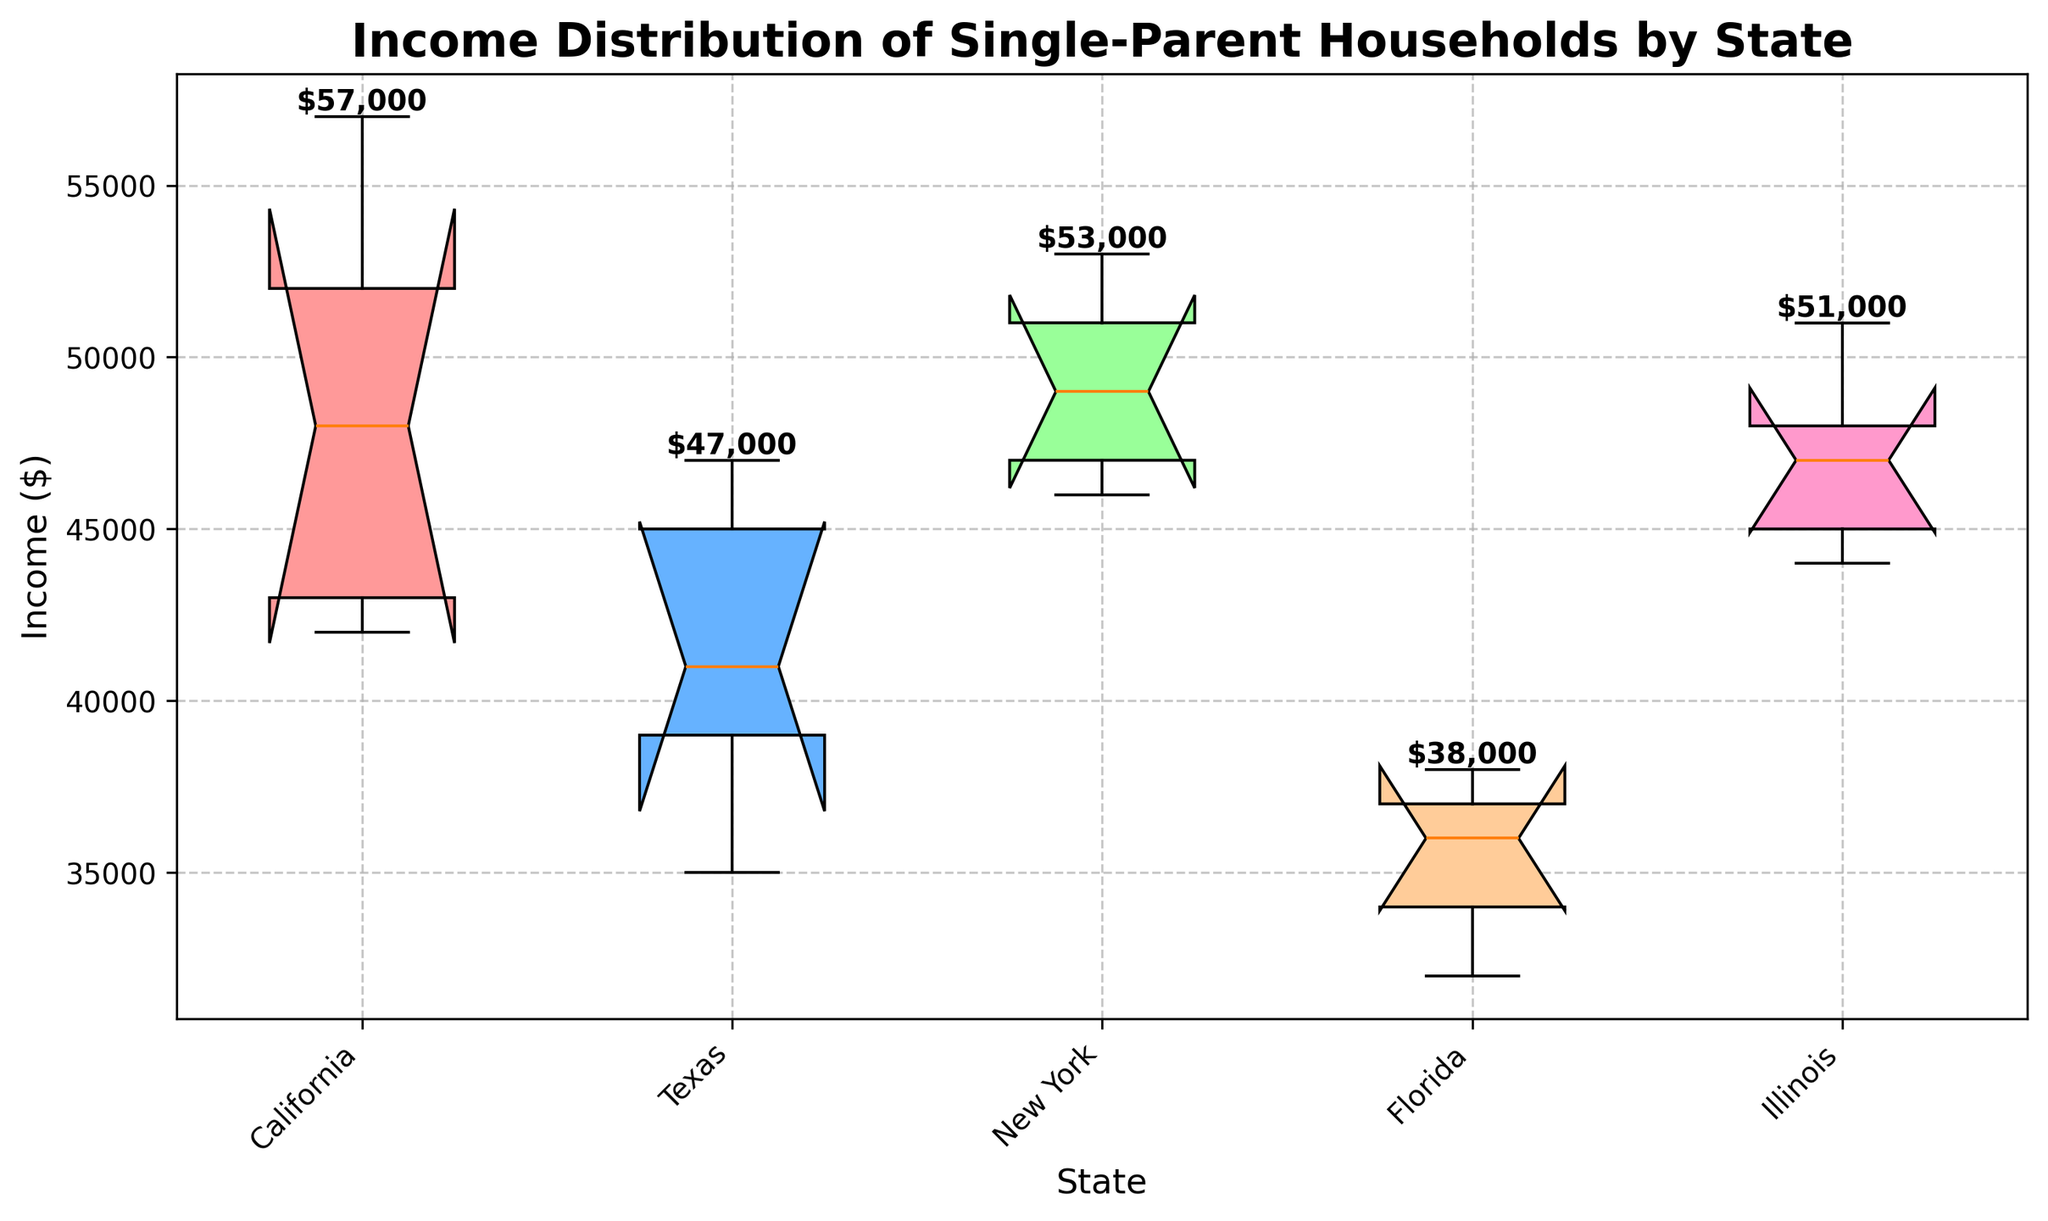What is the title of the plot? Look at the top of the plot where the title is usually displayed. The title should summarize the content of the plot.
Answer: Income Distribution of Single-Parent Households by State Which state has the highest maximum income? Observe the topmost points (whiskers) of the notched box plots for each state and identify which one goes the highest.
Answer: California What is the median income for New York? The median income is marked by the line inside the box of the notched plot for New York.
Answer: $49000 Which state has the lowest median income? Compare the lines representing the median incomes inside the boxes for all states.
Answer: Florida Compare the range of incomes in California and Florida. Which is larger? Calculate the difference between the maximum and minimum incomes (the whiskers) for California and Florida, then compare them.
Answer: California Do any states have overlapping interquartile ranges (the boxes)? Look at the boxes (the central part of each notched plot) and see if any boxes overlap vertically.
Answer: Yes What is the general trend in the income distribution among California and Texas? Evaluate the position of the median lines, the spread of the whiskers, and the overall height of the boxes.
Answer: California generally has higher and more spread-out incomes What color is used to represent the notched box plot for Texas? Identify the color used to fill the notched box plot corresponding to Texas based on the legend or by visual inspection.
Answer: Light Blue What is the upper whisker value for Illinois? Find the topmost whisker (line extending from the box) for Illinois and interpret the income value.
Answer: $51000 Which state has the most balanced (smallest) interquartile range? Compare the heights of the boxes (the central part of each notched box plot) and see which one is the smallest.
Answer: Florida 